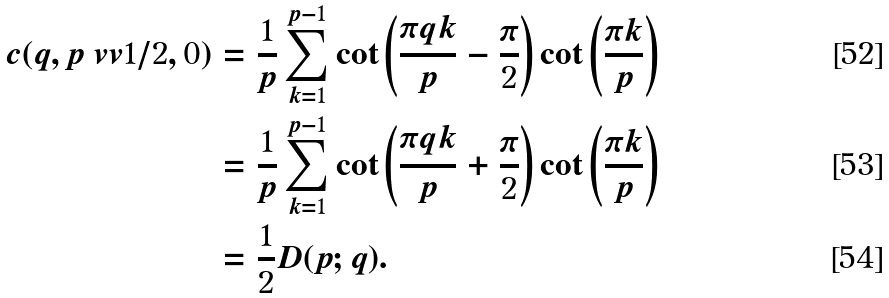<formula> <loc_0><loc_0><loc_500><loc_500>c ( q , p \ v v 1 / 2 , 0 ) & = \frac { 1 } { p } \sum _ { k = 1 } ^ { p - 1 } \cot \left ( \frac { \pi q k } { p } - \frac { \pi } { 2 } \right ) \cot \left ( \frac { \pi k } { p } \right ) \\ & = \frac { 1 } { p } \sum _ { k = 1 } ^ { p - 1 } \cot \left ( \frac { \pi q k } { p } + \frac { \pi } { 2 } \right ) \cot \left ( \frac { \pi k } { p } \right ) \\ & = \frac { 1 } { 2 } D ( p ; q ) .</formula> 